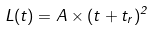<formula> <loc_0><loc_0><loc_500><loc_500>L ( t ) = A \times ( t + t _ { r } ) ^ { 2 }</formula> 